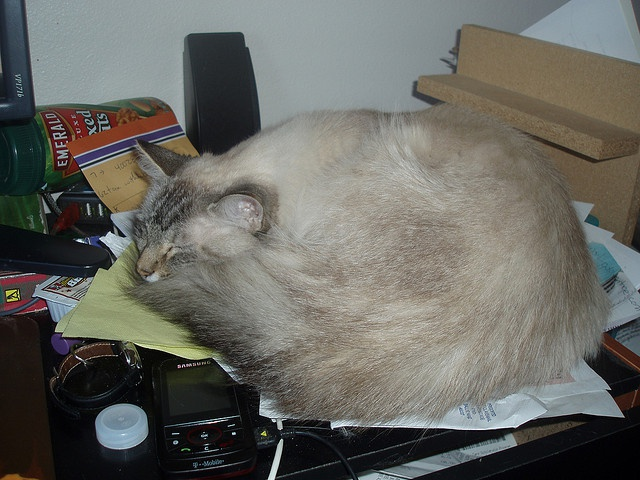Describe the objects in this image and their specific colors. I can see cat in black, darkgray, and gray tones, cell phone in black, gray, and darkgray tones, remote in black, gray, and darkgray tones, and tv in gray, black, and blue tones in this image. 